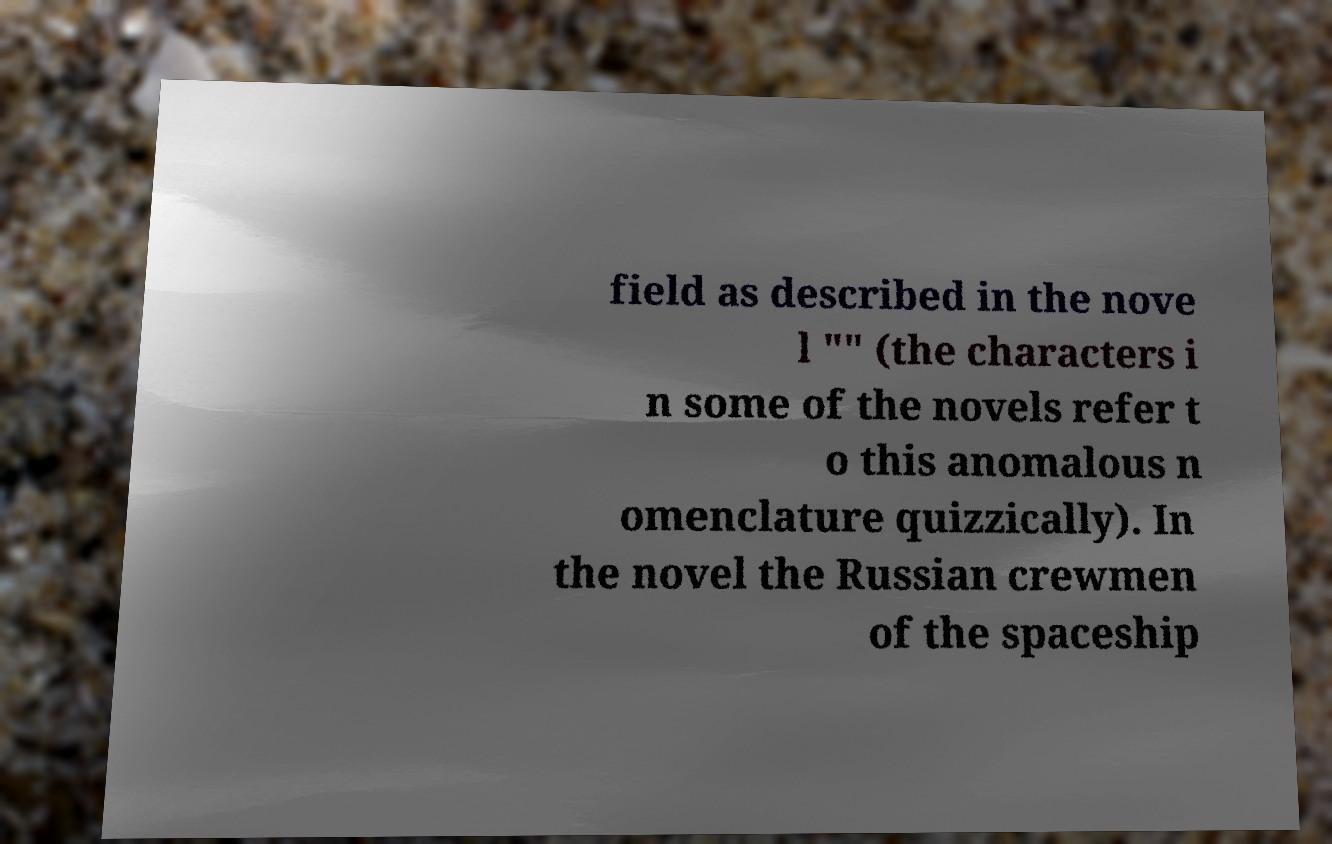Can you accurately transcribe the text from the provided image for me? field as described in the nove l "" (the characters i n some of the novels refer t o this anomalous n omenclature quizzically). In the novel the Russian crewmen of the spaceship 